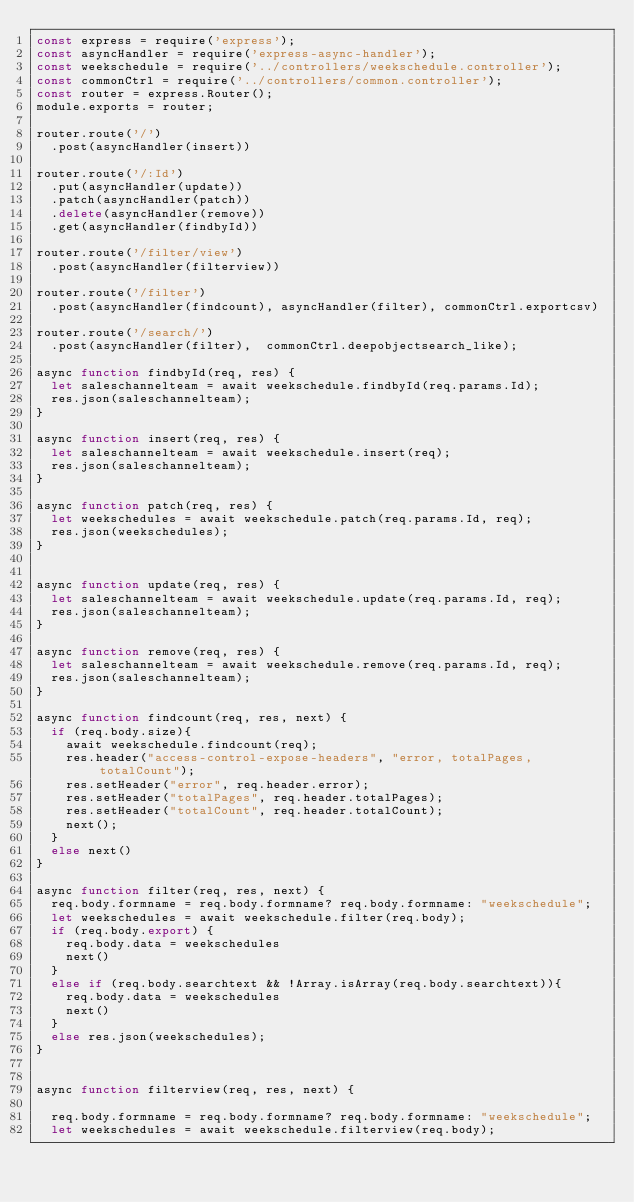<code> <loc_0><loc_0><loc_500><loc_500><_JavaScript_>const express = require('express');
const asyncHandler = require('express-async-handler');
const weekschedule = require('../controllers/weekschedule.controller');
const commonCtrl = require('../controllers/common.controller');
const router = express.Router();
module.exports = router;

router.route('/')
  .post(asyncHandler(insert))

router.route('/:Id')
  .put(asyncHandler(update))
  .patch(asyncHandler(patch))
  .delete(asyncHandler(remove))
  .get(asyncHandler(findbyId))

router.route('/filter/view')
  .post(asyncHandler(filterview))

router.route('/filter')
  .post(asyncHandler(findcount), asyncHandler(filter), commonCtrl.exportcsv)

router.route('/search/')
  .post(asyncHandler(filter),  commonCtrl.deepobjectsearch_like);

async function findbyId(req, res) {
  let saleschannelteam = await weekschedule.findbyId(req.params.Id);
  res.json(saleschannelteam);
}

async function insert(req, res) {
  let saleschannelteam = await weekschedule.insert(req);
  res.json(saleschannelteam);
}

async function patch(req, res) {
  let weekschedules = await weekschedule.patch(req.params.Id, req);
  res.json(weekschedules);
}


async function update(req, res) {
  let saleschannelteam = await weekschedule.update(req.params.Id, req);
  res.json(saleschannelteam);
}

async function remove(req, res) {
  let saleschannelteam = await weekschedule.remove(req.params.Id, req);
  res.json(saleschannelteam);
}

async function findcount(req, res, next) {
  if (req.body.size){
    await weekschedule.findcount(req);
    res.header("access-control-expose-headers", "error, totalPages, totalCount");
    res.setHeader("error", req.header.error);
    res.setHeader("totalPages", req.header.totalPages);
    res.setHeader("totalCount", req.header.totalCount);
    next();
  }
  else next()
}

async function filter(req, res, next) {
  req.body.formname = req.body.formname? req.body.formname: "weekschedule";
  let weekschedules = await weekschedule.filter(req.body);
  if (req.body.export) {
    req.body.data = weekschedules
    next()
  }
  else if (req.body.searchtext && !Array.isArray(req.body.searchtext)){
    req.body.data = weekschedules
    next()
  }
  else res.json(weekschedules);
}


async function filterview(req, res, next) {

  req.body.formname = req.body.formname? req.body.formname: "weekschedule";
  let weekschedules = await weekschedule.filterview(req.body);</code> 